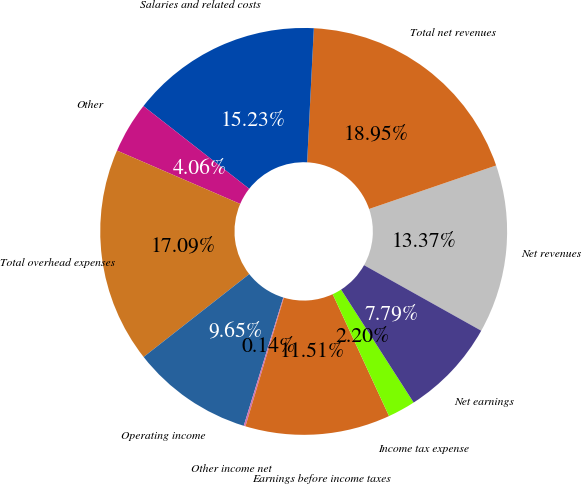Convert chart. <chart><loc_0><loc_0><loc_500><loc_500><pie_chart><fcel>Net revenues<fcel>Total net revenues<fcel>Salaries and related costs<fcel>Other<fcel>Total overhead expenses<fcel>Operating income<fcel>Other income net<fcel>Earnings before income taxes<fcel>Income tax expense<fcel>Net earnings<nl><fcel>13.37%<fcel>18.95%<fcel>15.23%<fcel>4.06%<fcel>17.09%<fcel>9.65%<fcel>0.14%<fcel>11.51%<fcel>2.2%<fcel>7.79%<nl></chart> 